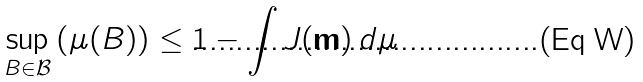<formula> <loc_0><loc_0><loc_500><loc_500>\sup _ { B \in { \mathcal { B } } } \left ( \mu ( B ) \right ) \leq 1 - \int J ( { \mathbf m } ) \, d \mu</formula> 